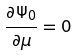Convert formula to latex. <formula><loc_0><loc_0><loc_500><loc_500>\frac { \partial \Psi _ { 0 } } { \partial \mu } = 0</formula> 